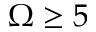<formula> <loc_0><loc_0><loc_500><loc_500>\Omega \geq 5</formula> 